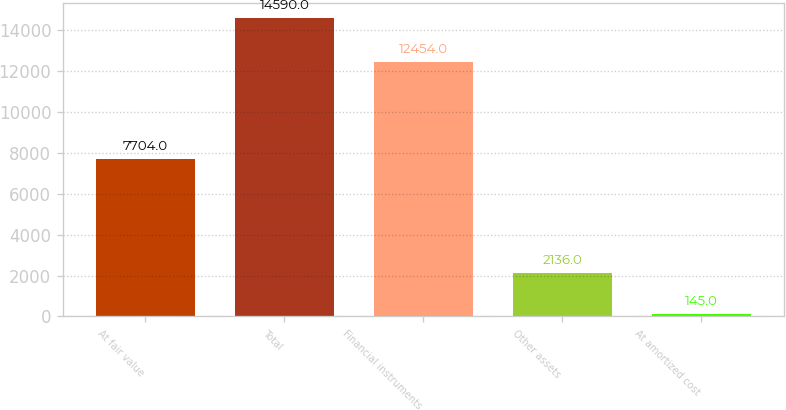Convert chart to OTSL. <chart><loc_0><loc_0><loc_500><loc_500><bar_chart><fcel>At fair value<fcel>Total<fcel>Financial instruments<fcel>Other assets<fcel>At amortized cost<nl><fcel>7704<fcel>14590<fcel>12454<fcel>2136<fcel>145<nl></chart> 